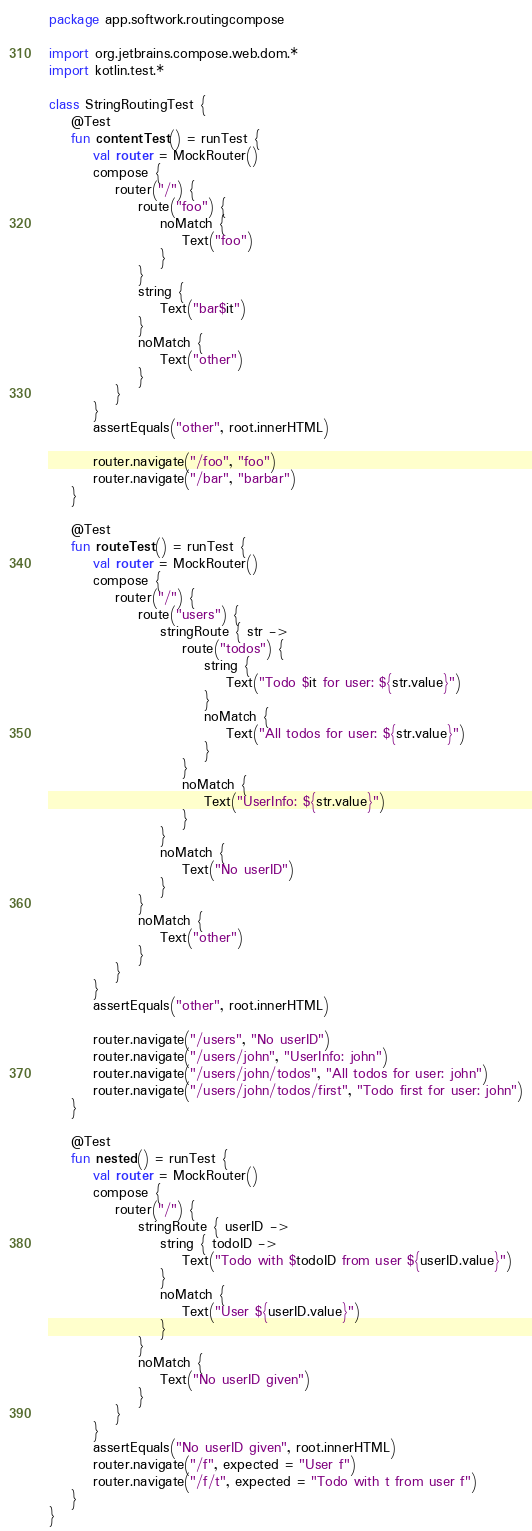<code> <loc_0><loc_0><loc_500><loc_500><_Kotlin_>package app.softwork.routingcompose

import org.jetbrains.compose.web.dom.*
import kotlin.test.*

class StringRoutingTest {
    @Test
    fun contentTest() = runTest {
        val router = MockRouter()
        compose {
            router("/") {
                route("foo") {
                    noMatch {
                        Text("foo")
                    }
                }
                string {
                    Text("bar$it")
                }
                noMatch {
                    Text("other")
                }
            }
        }
        assertEquals("other", root.innerHTML)

        router.navigate("/foo", "foo")
        router.navigate("/bar", "barbar")
    }

    @Test
    fun routeTest() = runTest {
        val router = MockRouter()
        compose {
            router("/") {
                route("users") {
                    stringRoute { str ->
                        route("todos") {
                            string {
                                Text("Todo $it for user: ${str.value}")
                            }
                            noMatch {
                                Text("All todos for user: ${str.value}")
                            }
                        }
                        noMatch {
                            Text("UserInfo: ${str.value}")
                        }
                    }
                    noMatch {
                        Text("No userID")
                    }
                }
                noMatch {
                    Text("other")
                }
            }
        }
        assertEquals("other", root.innerHTML)

        router.navigate("/users", "No userID")
        router.navigate("/users/john", "UserInfo: john")
        router.navigate("/users/john/todos", "All todos for user: john")
        router.navigate("/users/john/todos/first", "Todo first for user: john")
    }

    @Test
    fun nested() = runTest {
        val router = MockRouter()
        compose {
            router("/") {
                stringRoute { userID ->
                    string { todoID ->
                        Text("Todo with $todoID from user ${userID.value}")
                    }
                    noMatch {
                        Text("User ${userID.value}")
                    }
                }
                noMatch {
                    Text("No userID given")
                }
            }
        }
        assertEquals("No userID given", root.innerHTML)
        router.navigate("/f", expected = "User f")
        router.navigate("/f/t", expected = "Todo with t from user f")
    }
}</code> 